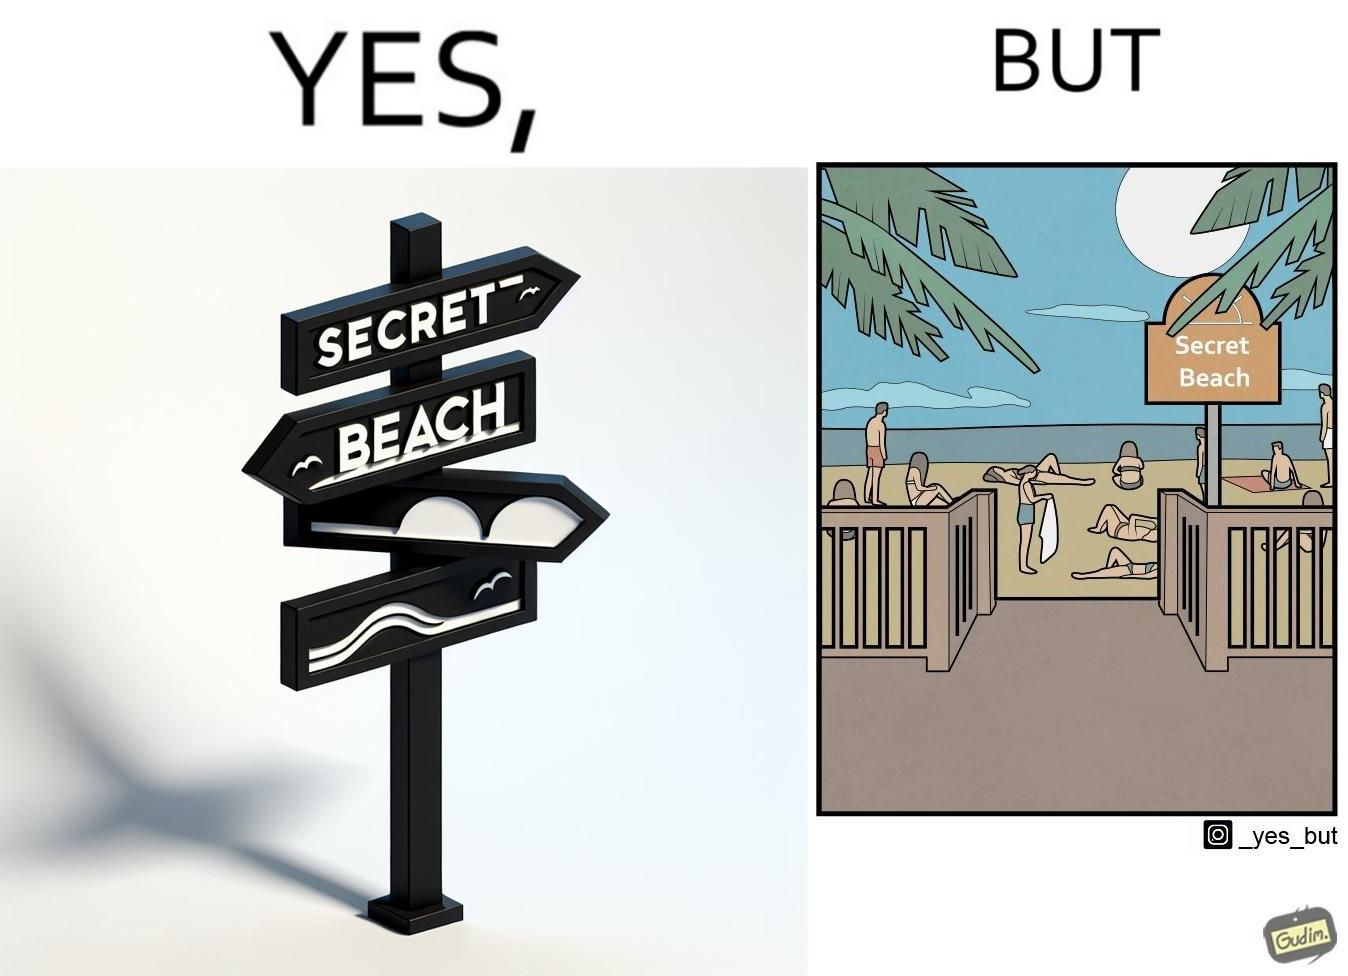Does this image contain satire or humor? Yes, this image is satirical. 